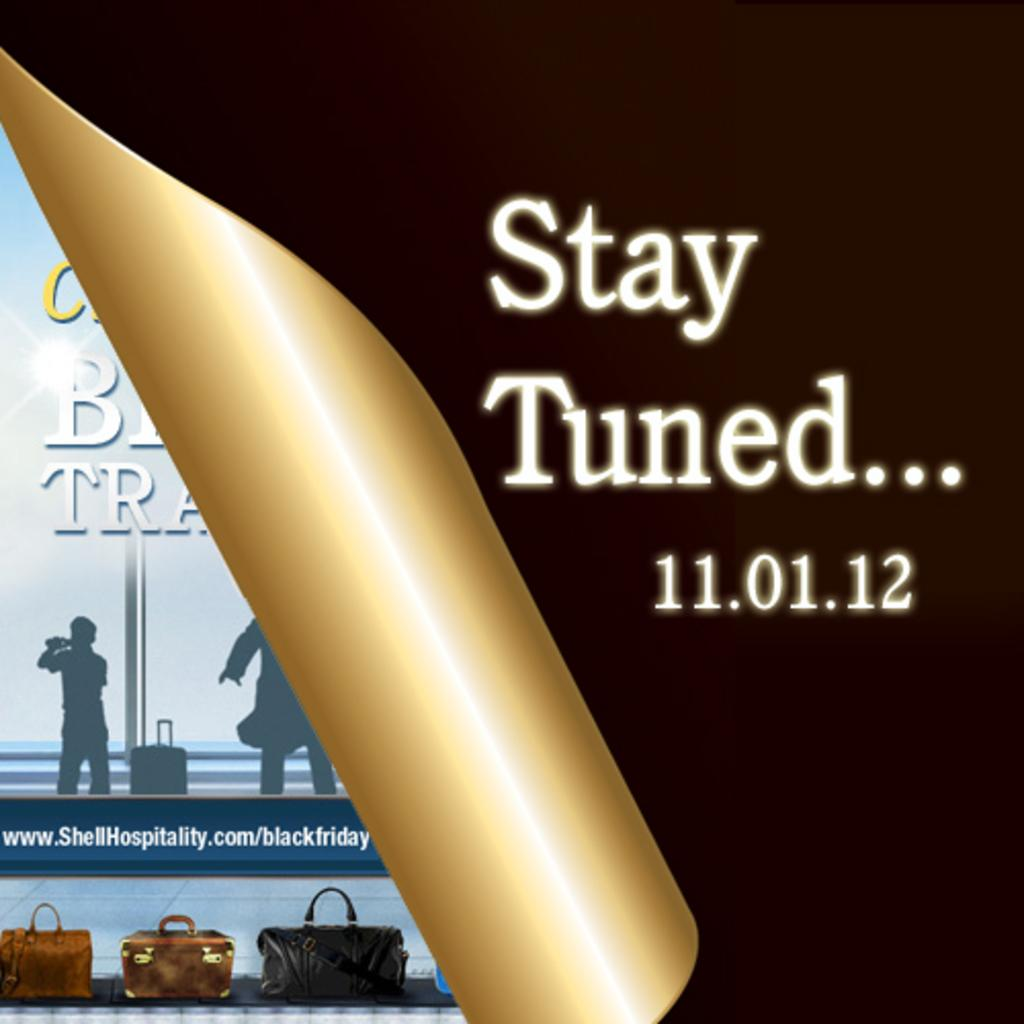What is present in the image that contains both images and text? There is a poster in the image that contains images and text. What type of note is the toad holding in the image? There is no toad or note present in the image; it only contains a poster with images and text. 